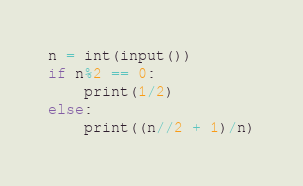Convert code to text. <code><loc_0><loc_0><loc_500><loc_500><_Python_>n = int(input())
if n%2 == 0:
    print(1/2)
else:
    print((n//2 + 1)/n)
</code> 